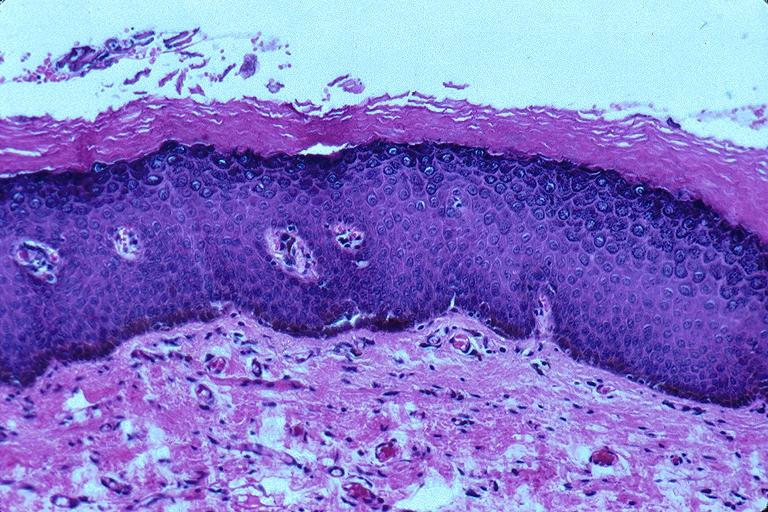does lower chest and abdomen anterior show epithelial hyperplasia and hyperkeratosis?
Answer the question using a single word or phrase. No 